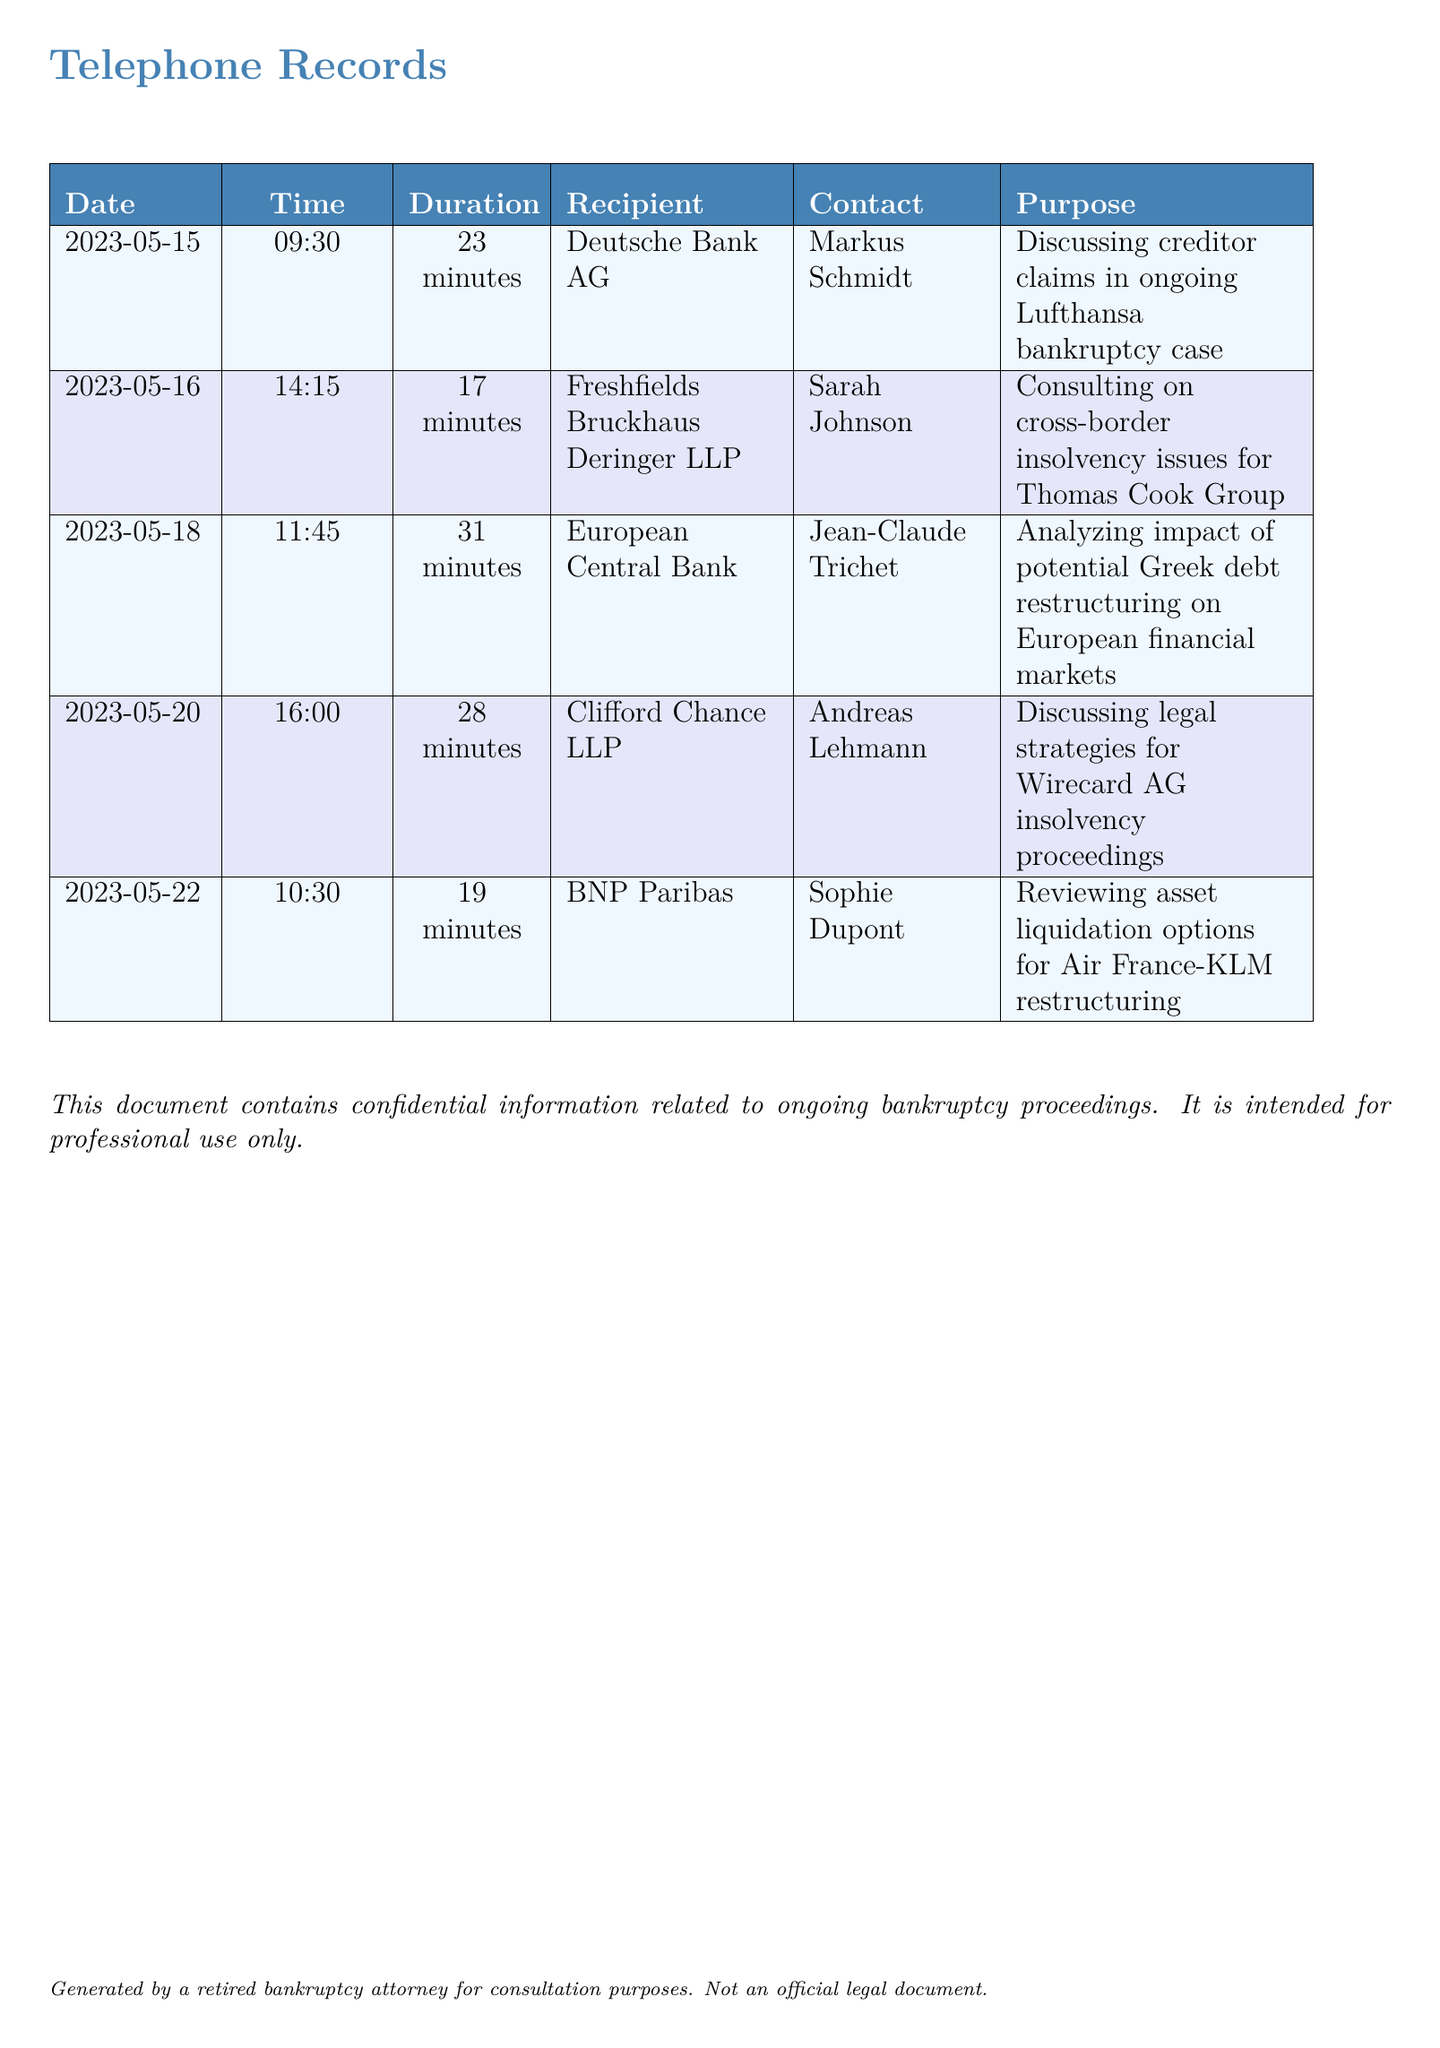What is the duration of the call with Deutsche Bank AG? The duration is found in the table under the "Duration" column for the corresponding date and recipient.
Answer: 23 minutes Who was the recipient of the call on May 20? The recipient's name is listed in the "Recipient" column for that date in the table.
Answer: Clifford Chance LLP What is the purpose of the call with Freshfields Bruckhaus Deringer LLP? The purpose is detailed in the "Purpose" column for that entry of the document.
Answer: Consulting on cross-border insolvency issues for Thomas Cook Group How many calls were made in total? The total number of calls can be counted from the number of entries in the table.
Answer: 5 What organization did Sarah Johnson represent? The organization is indicated in the "Recipient" column for that particular entry.
Answer: Freshfields Bruckhaus Deringer LLP Which call took the longest duration? The longest duration can be evaluated by comparing the durations listed in the "Duration" column.
Answer: 31 minutes What was the date of the call discussing legal strategies for Wirecard AG? The date is found in the "Date" column corresponding to that specific recipient and purpose.
Answer: 2023-05-20 